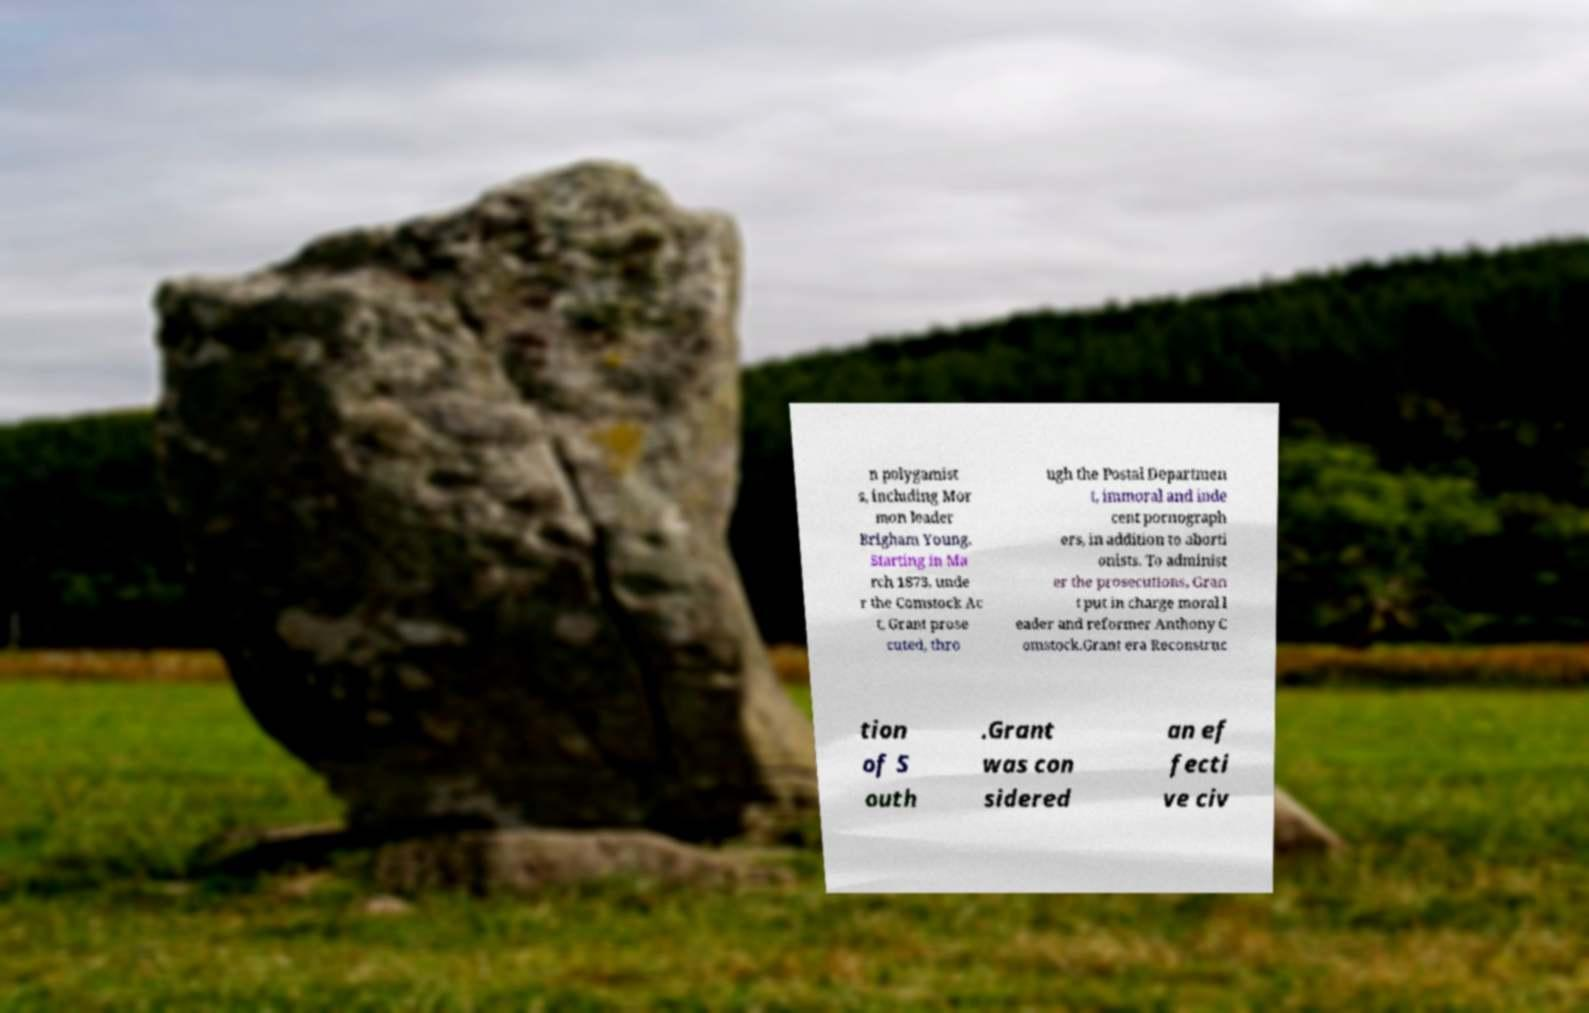What messages or text are displayed in this image? I need them in a readable, typed format. n polygamist s, including Mor mon leader Brigham Young. Starting in Ma rch 1873, unde r the Comstock Ac t, Grant prose cuted, thro ugh the Postal Departmen t, immoral and inde cent pornograph ers, in addition to aborti onists. To administ er the prosecutions, Gran t put in charge moral l eader and reformer Anthony C omstock.Grant era Reconstruc tion of S outh .Grant was con sidered an ef fecti ve civ 